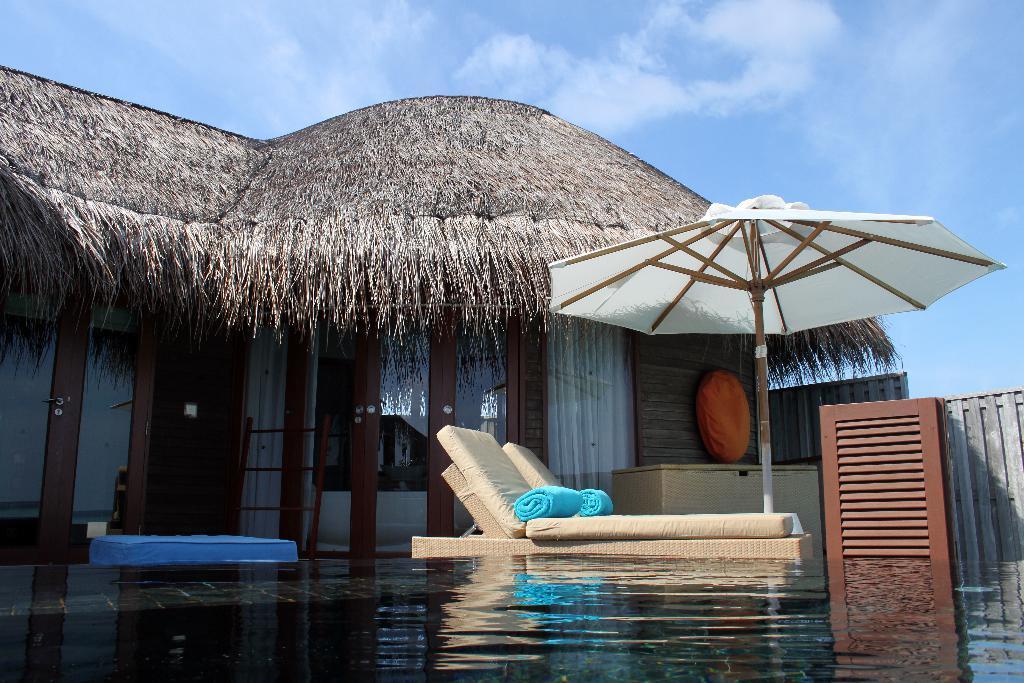Could you give a brief overview of what you see in this image? In this image, we can see water and there is a rest chair, we can see an umbrella, there is a house with a thatched roof. 